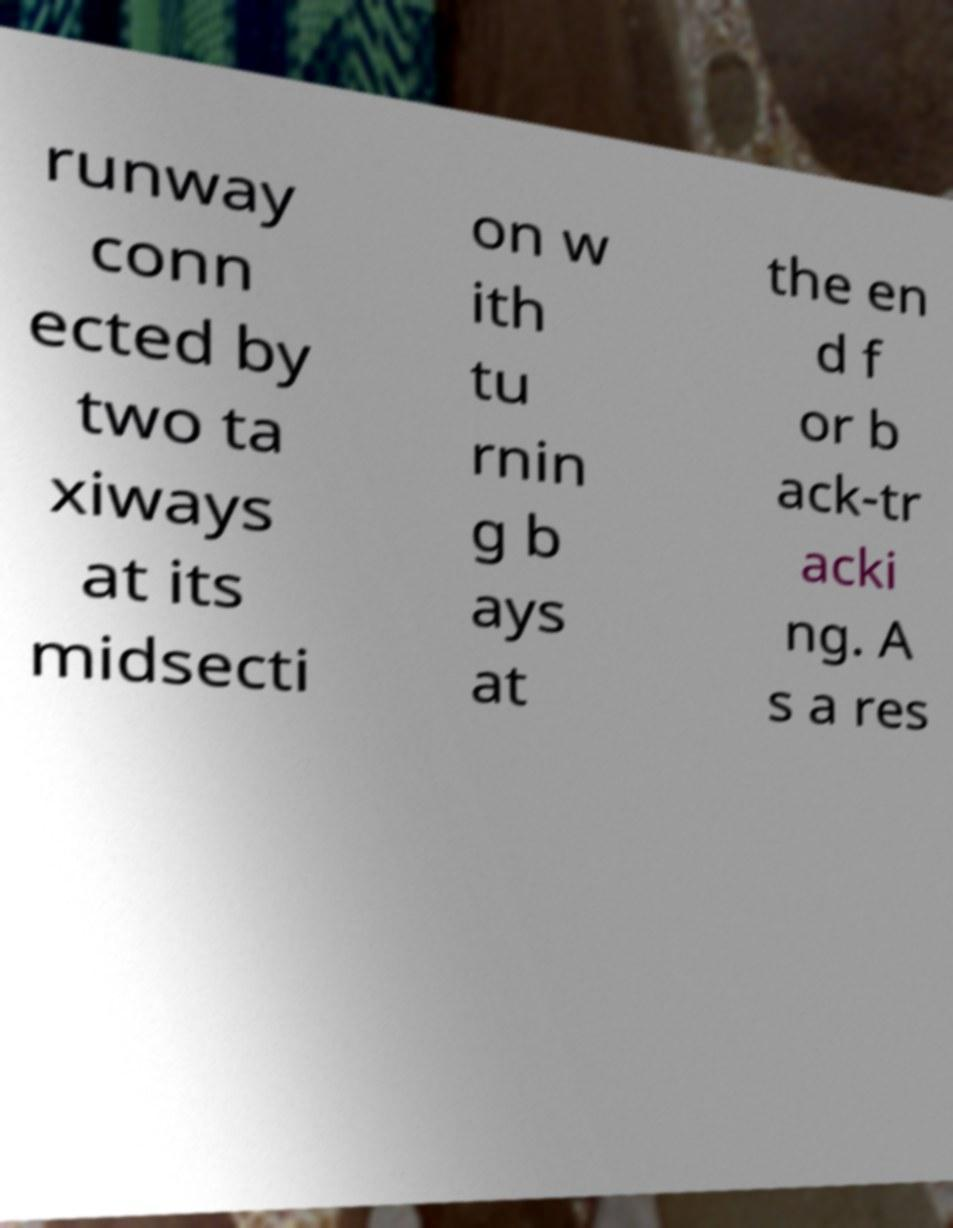Can you read and provide the text displayed in the image?This photo seems to have some interesting text. Can you extract and type it out for me? runway conn ected by two ta xiways at its midsecti on w ith tu rnin g b ays at the en d f or b ack-tr acki ng. A s a res 